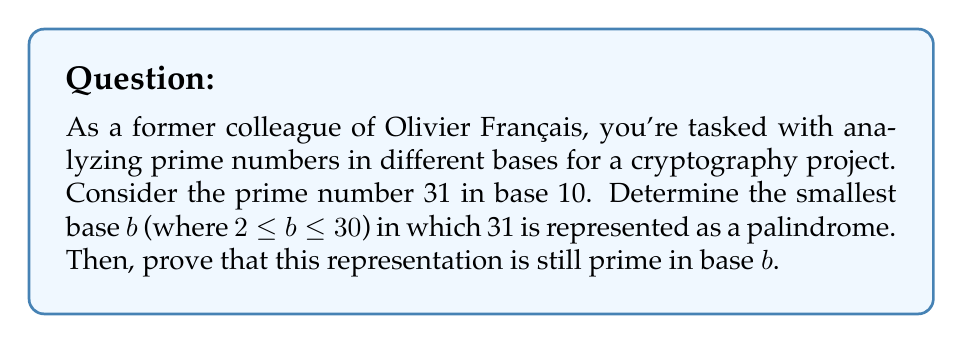Solve this math problem. 1) First, let's convert 31 to different bases until we find a palindrome:

   Base 2: 11111
   Base 3: 1012
   Base 4: 133
   Base 5: 111 (palindrome found)

2) Therefore, the smallest base $b$ where 31 is a palindrome is 5.

3) In base 5, 31 is represented as $111_5$.

4) To prove that $111_5$ is prime in base 5, we need to show that it has no factors other than 1 and itself in base 5.

5) In base 5, the possible single-digit factors are 2, 3, and 4 (1 and 5 are trivial).

6) Let's perform division in base 5:

   $111_5 \div 2_5$:
   $$\begin{array}{r}
   22_5 \\
   2_5 \enclose{longdiv}{111_5} \\
      \underline{11_5} \\
      01_5 \\
      \underline{1_5} \\
      0_5
   \end{array}$$

   $111_5 \div 3_5$:
   $$\begin{array}{r}
   12_5 \\
   3_5 \enclose{longdiv}{111_5} \\
      \underline{11_5} \\
      01_5 \\
      \underline{1_5} \\
      0_5
   \end{array}$$

   $111_5 \div 4_5$:
   $$\begin{array}{r}
   11_5 \\
   4_5 \enclose{longdiv}{111_5} \\
      \underline{11_5} \\
      00_5 \\
      \underline{0_5} \\
      0_5
   \end{array}$$

7) None of these divisions result in a whole number in base 5, proving that $111_5$ has no factors other than 1 and itself in base 5.

Therefore, $111_5$ is prime in base 5.
Answer: 5 